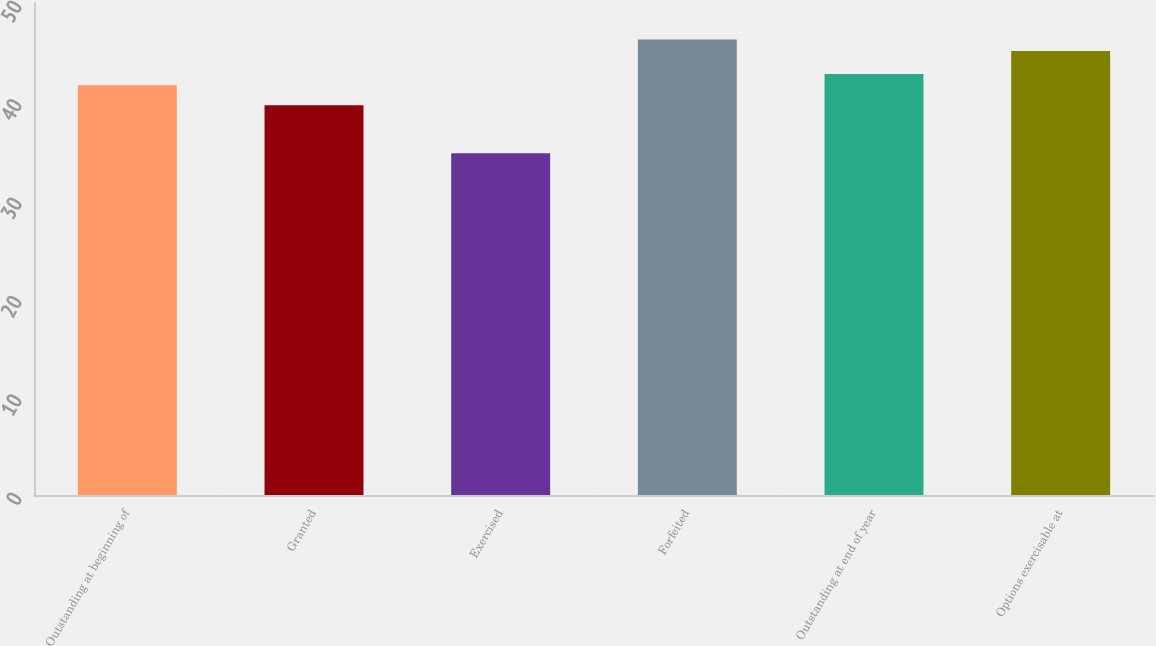<chart> <loc_0><loc_0><loc_500><loc_500><bar_chart><fcel>Outstanding at beginning of<fcel>Granted<fcel>Exercised<fcel>Forfeited<fcel>Outstanding at end of year<fcel>Options exercisable at<nl><fcel>41.63<fcel>39.61<fcel>34.74<fcel>46.28<fcel>42.78<fcel>45.13<nl></chart> 